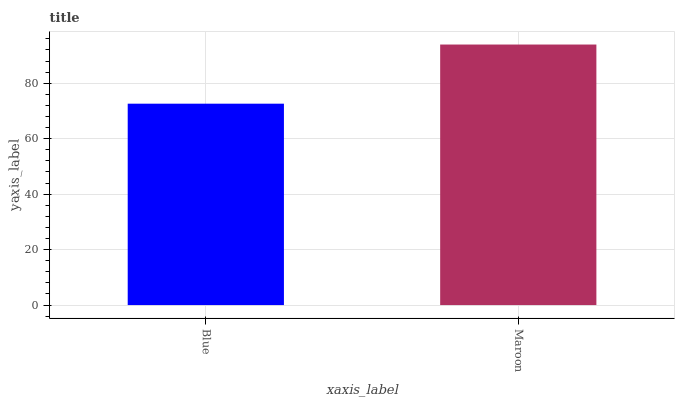Is Blue the minimum?
Answer yes or no. Yes. Is Maroon the maximum?
Answer yes or no. Yes. Is Maroon the minimum?
Answer yes or no. No. Is Maroon greater than Blue?
Answer yes or no. Yes. Is Blue less than Maroon?
Answer yes or no. Yes. Is Blue greater than Maroon?
Answer yes or no. No. Is Maroon less than Blue?
Answer yes or no. No. Is Maroon the high median?
Answer yes or no. Yes. Is Blue the low median?
Answer yes or no. Yes. Is Blue the high median?
Answer yes or no. No. Is Maroon the low median?
Answer yes or no. No. 